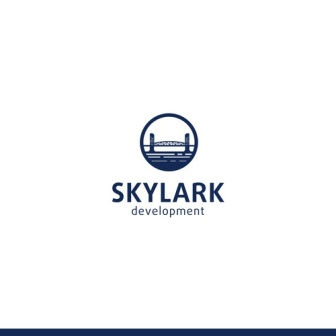What's happening in the scene? The image showcases a logo for a company named 'Skylark Development.' The logo features a blue and white color scheme, with a central blue circle outlined in white. Inside the circle is a stylized city skyline, including various buildings and a bridge, all silhouetted in blue against a white background. Above the circle, the word 'SKYLARK' is prominently displayed in bold, capital letters, while the word 'development' is written below in a smaller, more understated font. This design suggests the company is engaged in urban development or construction, evoking a sense of modernity and progress. 